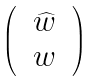Convert formula to latex. <formula><loc_0><loc_0><loc_500><loc_500>\begin{pmatrix} & \widehat { w } & \\ & w & \end{pmatrix}</formula> 